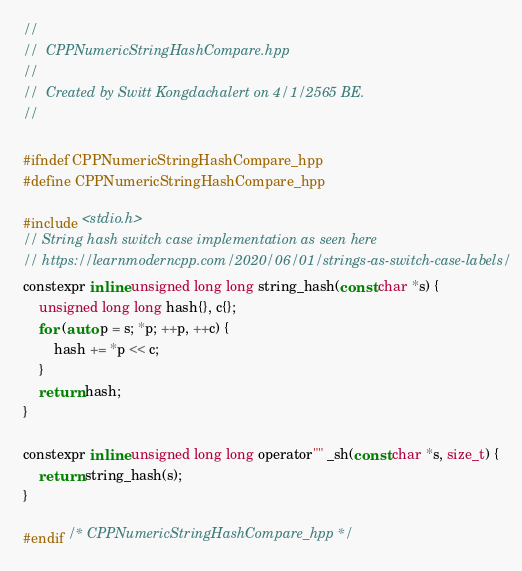Convert code to text. <code><loc_0><loc_0><loc_500><loc_500><_C_>//
//  CPPNumericStringHashCompare.hpp
//
//  Created by Switt Kongdachalert on 4/1/2565 BE.
//

#ifndef CPPNumericStringHashCompare_hpp
#define CPPNumericStringHashCompare_hpp

#include <stdio.h>
// String hash switch case implementation as seen here
// https://learnmoderncpp.com/2020/06/01/strings-as-switch-case-labels/
constexpr inline unsigned long long string_hash(const char *s) {
    unsigned long long hash{}, c{};
    for (auto p = s; *p; ++p, ++c) {
        hash += *p << c;
    }
    return hash;
}

constexpr inline unsigned long long operator"" _sh(const char *s, size_t) {
    return string_hash(s);
}

#endif /* CPPNumericStringHashCompare_hpp */
</code> 